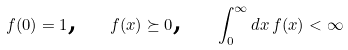<formula> <loc_0><loc_0><loc_500><loc_500>f ( 0 ) = 1 \text {, \ \ } f ( x ) \succeq 0 \text {, \ \ } \int _ { 0 } ^ { \infty } d x \, f ( x ) < \infty</formula> 